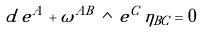<formula> <loc_0><loc_0><loc_500><loc_500>d \, e ^ { A } + \omega ^ { A B } \, \wedge \, e ^ { C } \, \eta _ { B C } = 0</formula> 